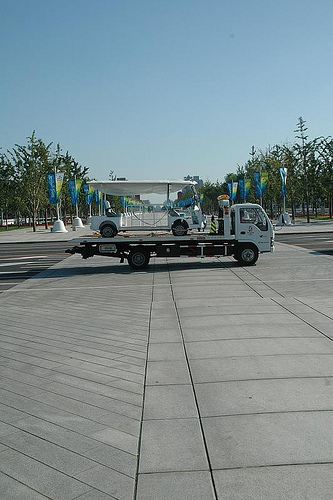<image>
Can you confirm if the vehicle is on the truck? Yes. Looking at the image, I can see the vehicle is positioned on top of the truck, with the truck providing support. Is there a wheel on the floor? No. The wheel is not positioned on the floor. They may be near each other, but the wheel is not supported by or resting on top of the floor. 